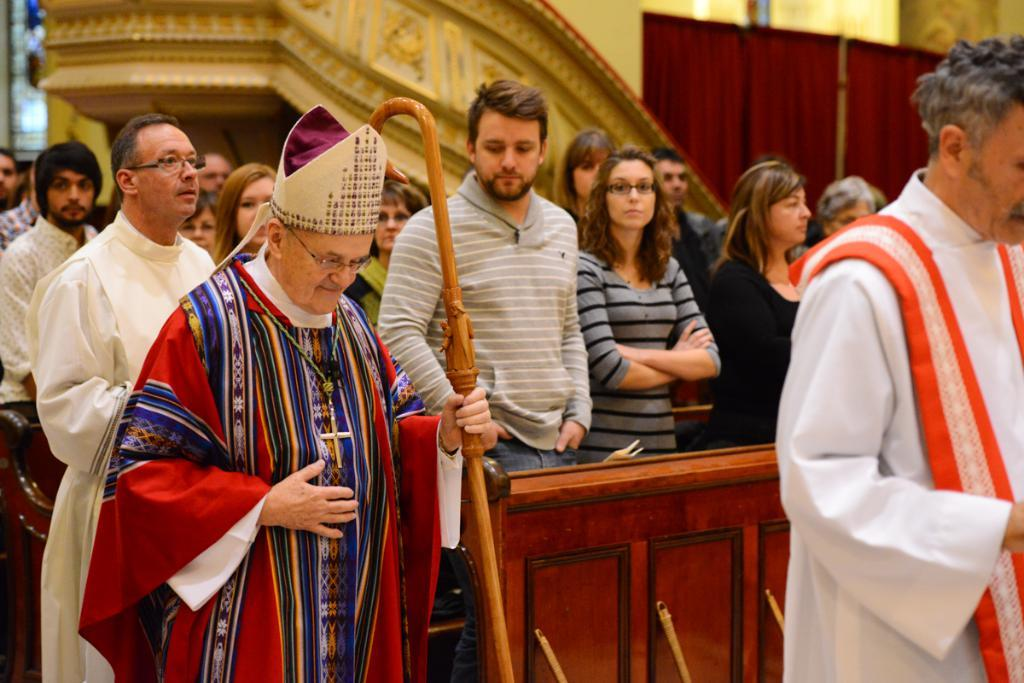What is happening in the image? There are people standing in the image. Can you describe the clothing of the people? The people are wearing different color dresses. What object is one person holding? One person is holding a wooden stick. What type of background can be seen in the image? There is a maroon curtain and a wall visible in the image. What type of lamp is hanging from the ceiling in the image? There is no lamp visible in the image. 